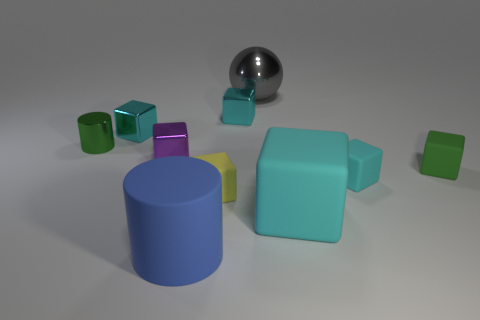Subtract all purple balls. How many cyan blocks are left? 4 Subtract all green blocks. How many blocks are left? 6 Subtract all small cyan cubes. How many cubes are left? 4 Subtract all yellow blocks. Subtract all green spheres. How many blocks are left? 6 Subtract all balls. How many objects are left? 9 Subtract 1 purple blocks. How many objects are left? 9 Subtract all large red rubber balls. Subtract all tiny green metallic objects. How many objects are left? 9 Add 3 green rubber cubes. How many green rubber cubes are left? 4 Add 3 big shiny balls. How many big shiny balls exist? 4 